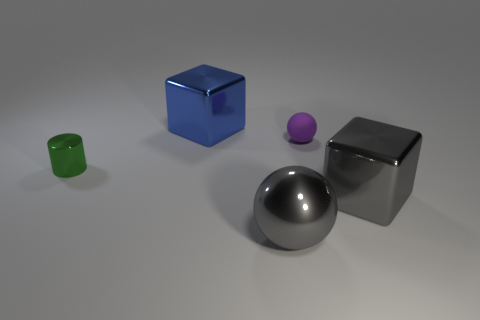Are there any other things that are the same shape as the tiny green object?
Offer a very short reply. No. What number of metal things are either blocks or blue things?
Offer a very short reply. 2. There is a big metal thing in front of the large gray block; is it the same shape as the small object that is right of the metallic cylinder?
Offer a terse response. Yes. There is a blue block; how many cubes are in front of it?
Your response must be concise. 1. Are there any large blue cubes that have the same material as the tiny green cylinder?
Make the answer very short. Yes. There is a purple thing that is the same size as the shiny cylinder; what is it made of?
Offer a very short reply. Rubber. Do the green thing and the blue object have the same material?
Your answer should be very brief. Yes. How many things are metal cylinders or big yellow rubber cylinders?
Your answer should be very brief. 1. There is a gray metal thing that is in front of the gray metallic cube; what shape is it?
Ensure brevity in your answer.  Sphere. What is the color of the small cylinder that is the same material as the large blue cube?
Offer a terse response. Green. 